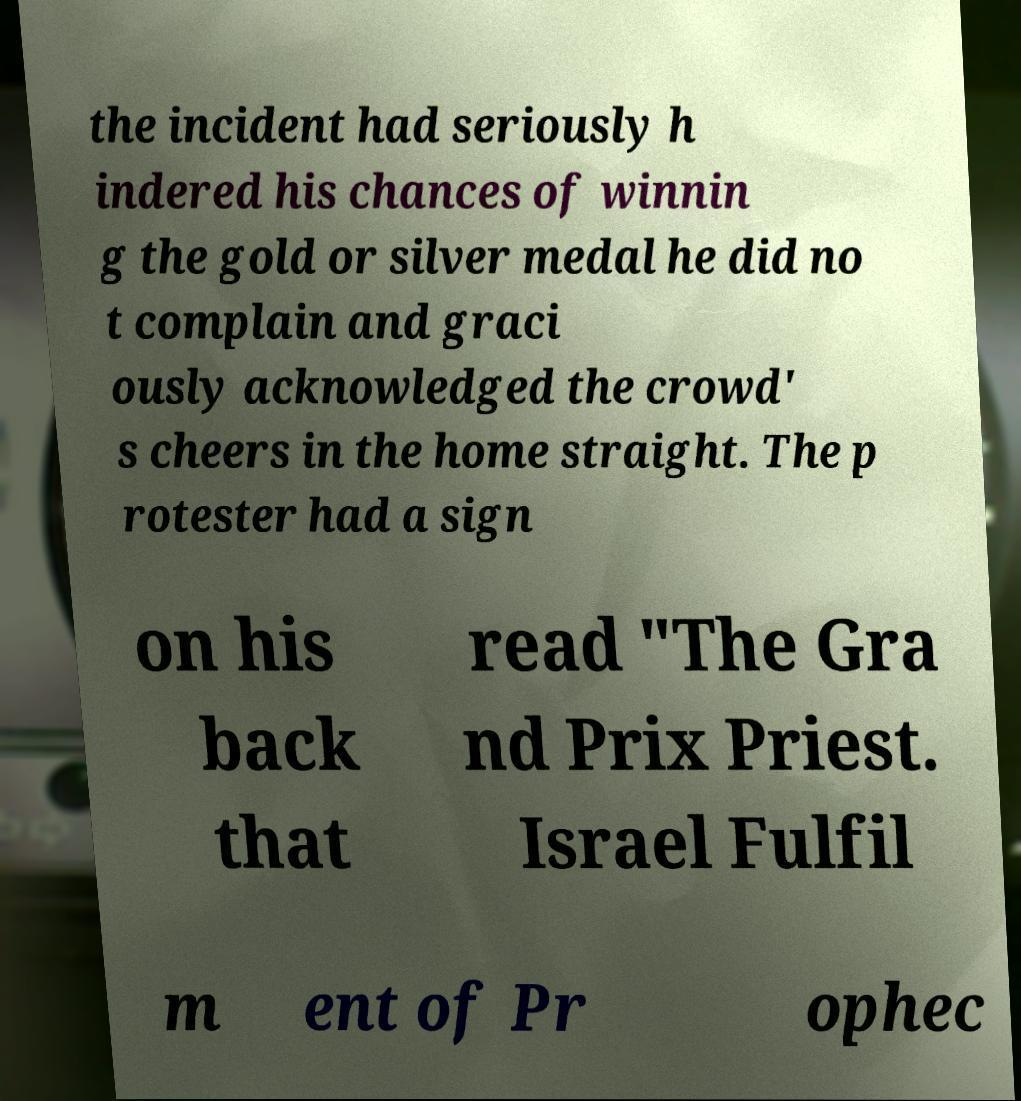Please identify and transcribe the text found in this image. the incident had seriously h indered his chances of winnin g the gold or silver medal he did no t complain and graci ously acknowledged the crowd' s cheers in the home straight. The p rotester had a sign on his back that read "The Gra nd Prix Priest. Israel Fulfil m ent of Pr ophec 